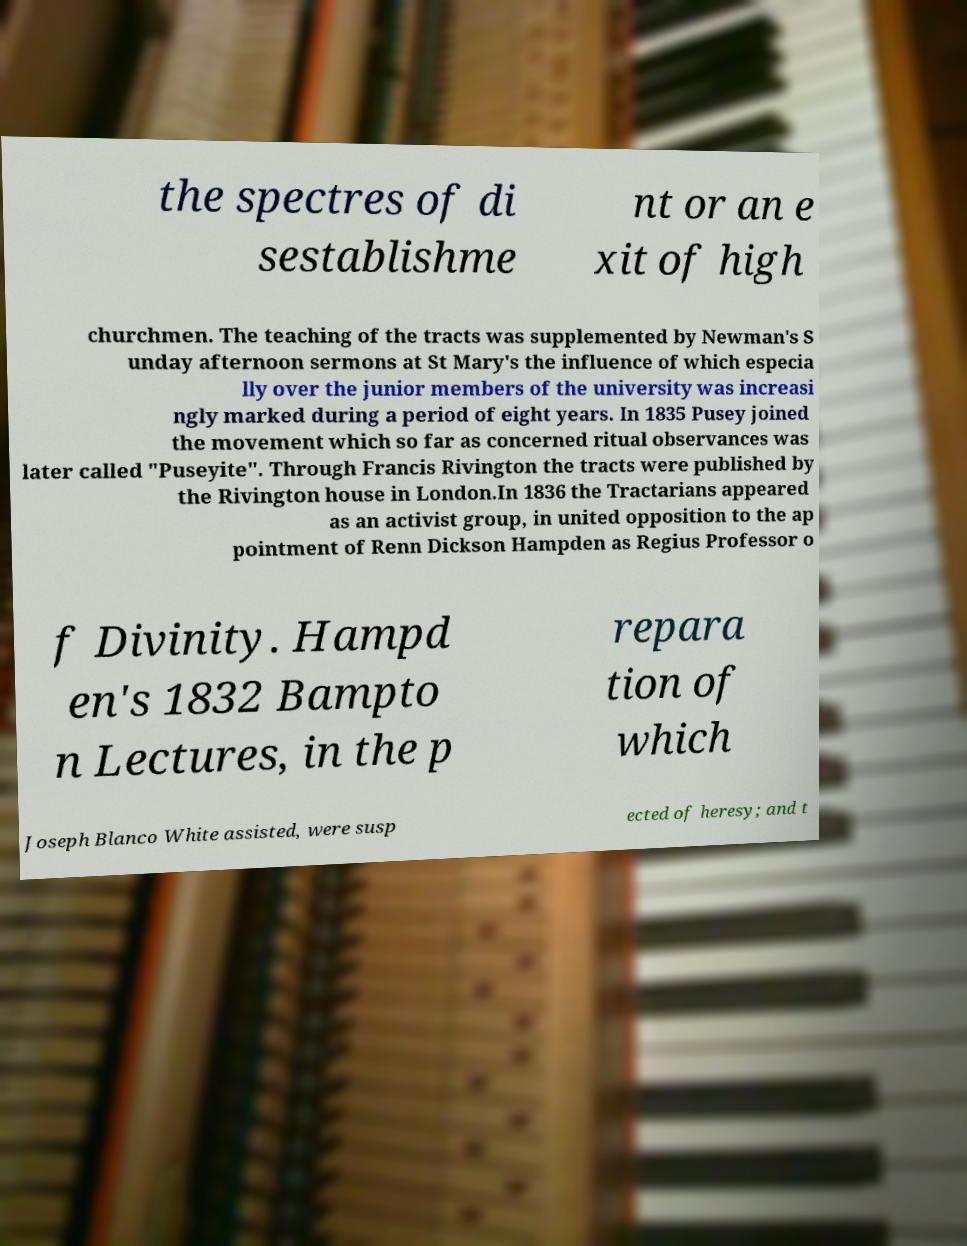Please read and relay the text visible in this image. What does it say? the spectres of di sestablishme nt or an e xit of high churchmen. The teaching of the tracts was supplemented by Newman's S unday afternoon sermons at St Mary's the influence of which especia lly over the junior members of the university was increasi ngly marked during a period of eight years. In 1835 Pusey joined the movement which so far as concerned ritual observances was later called "Puseyite". Through Francis Rivington the tracts were published by the Rivington house in London.In 1836 the Tractarians appeared as an activist group, in united opposition to the ap pointment of Renn Dickson Hampden as Regius Professor o f Divinity. Hampd en's 1832 Bampto n Lectures, in the p repara tion of which Joseph Blanco White assisted, were susp ected of heresy; and t 